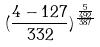<formula> <loc_0><loc_0><loc_500><loc_500>( \frac { 4 - 1 2 7 } { 3 3 2 } ) ^ { \frac { \frac { 5 } { 4 9 2 } } { 3 8 7 } }</formula> 